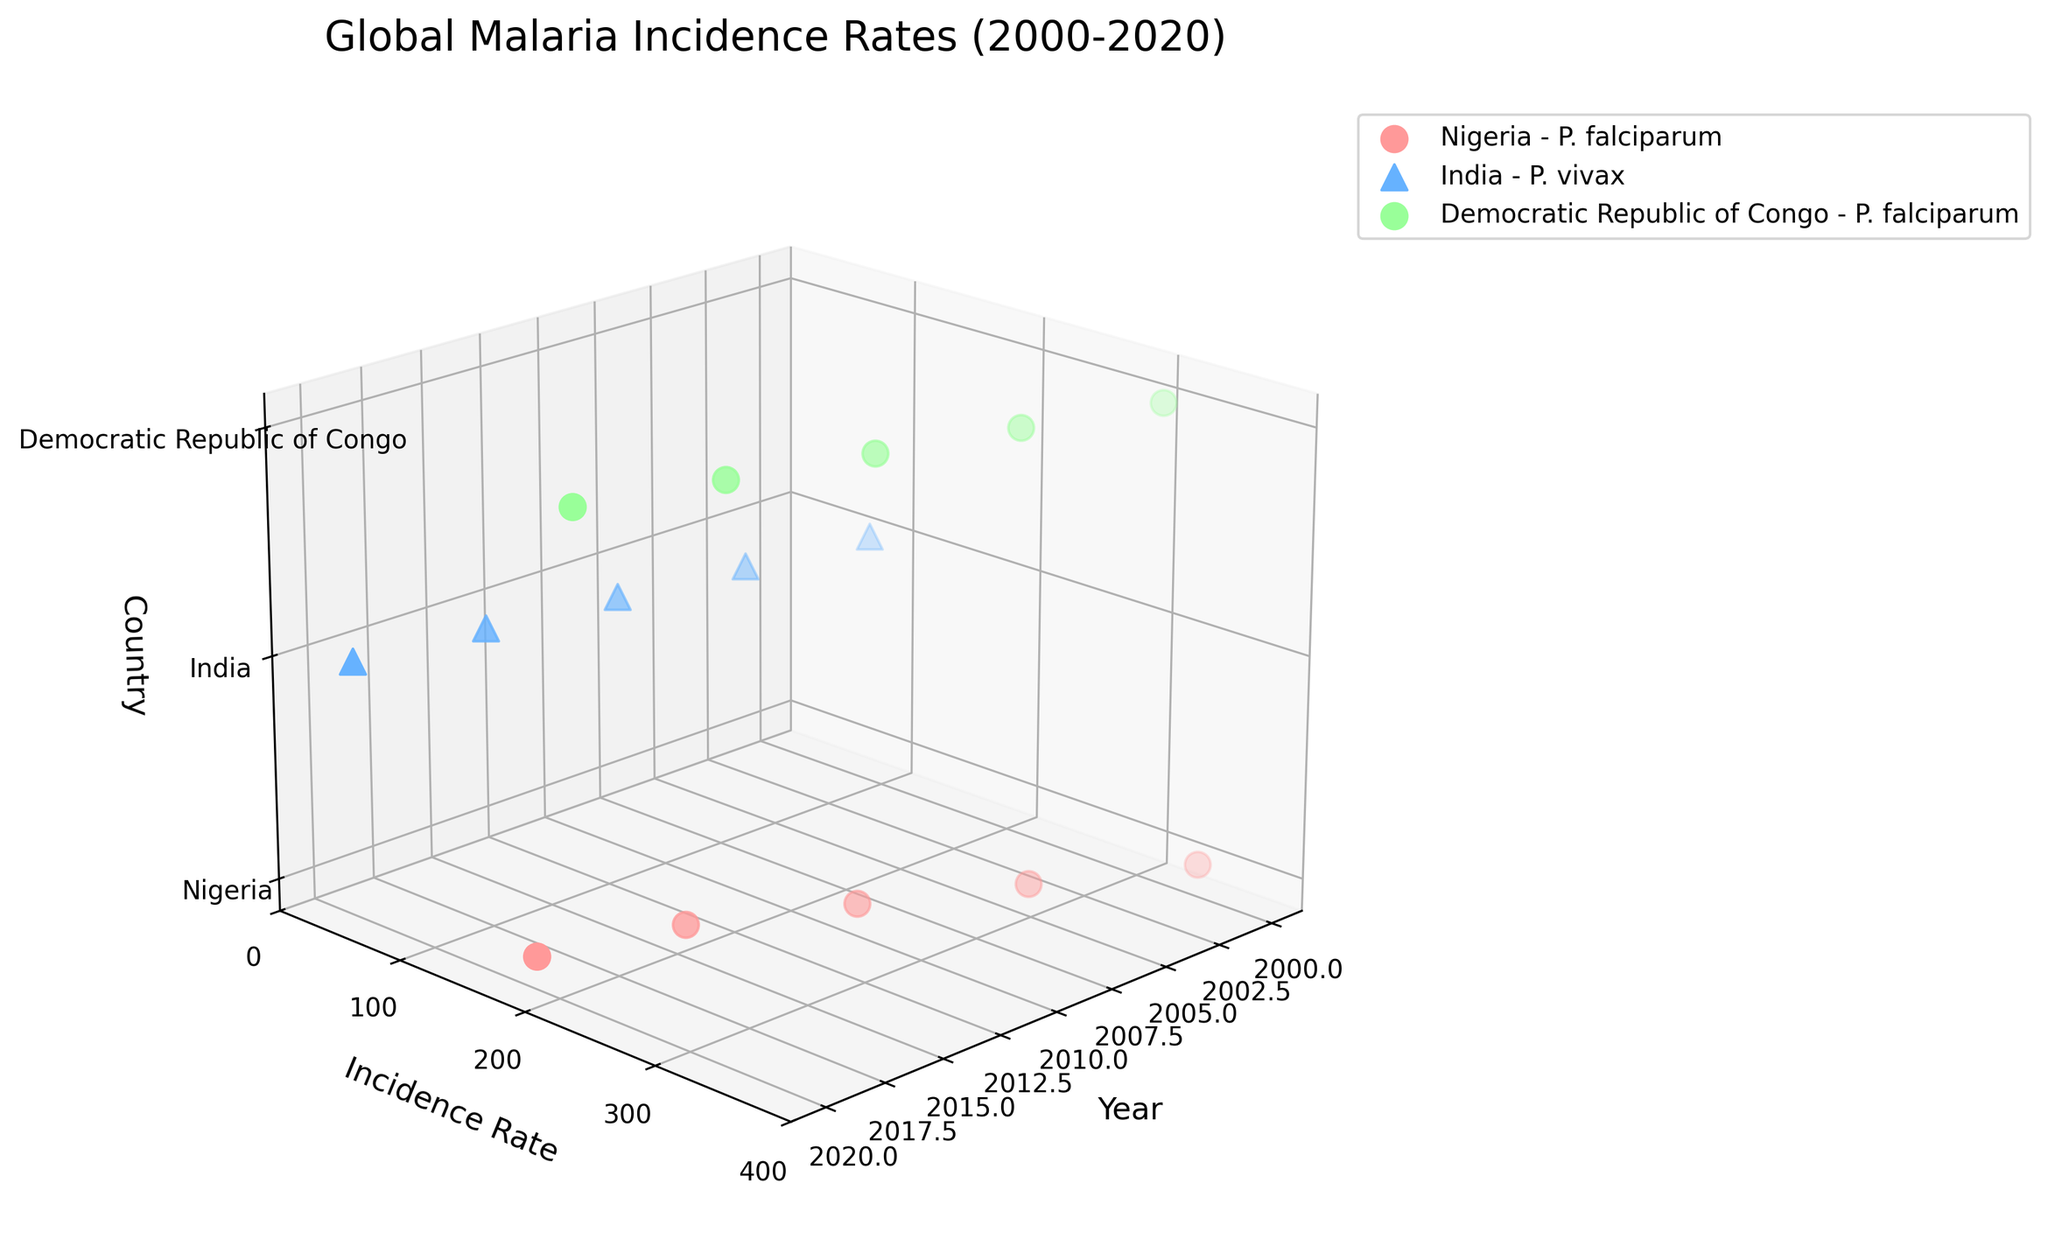What's the title of the figure? The title is located at the top of the figure and it is supposed to summarize the overall content.
Answer: Global Malaria Incidence Rates (2000-2020) Which country has the highest malaria incidence rate in 2020? To find the highest incidence rate in 2020, look at the data points for the year 2020 along the x-axis and then compare the incidence rates (y-axis) for each country (z-axis).
Answer: Nigeria What is the trend of malaria incidence rates in Nigeria over the years? Observe the data points for Nigeria distributed along the x-axis (years) and see how the y-axis values (incidence rates) change over time.
Answer: Decreasing Which Plasmodium species is present in India according to the figure? Identify the markers (shapes) associated with data points for India. The legend explains which shapes correspond to which Plasmodium species.
Answer: P. vivax What color represents Nigeria in the plot? Using the legend, locate the color associated with Nigeria's data points.
Answer: Red What is the difference in the malaria incidence rate of Nigeria between 2000 and 2020? Find and note down the incidence rates for Nigeria in the years 2000 and 2020 and then compute the difference.
Answer: 162.9 Which country showed a decreasing incidence rate for P. falciparum from 2000 to 2015? Identify the data points for P. falciparum (marker type) from 2000 to 2015 and examine their trends in each country.
Answer: Democratic Republic of Congo How does the incidence rate trend in India compare between 2005 and 2010? Locate the incidence rates for India in the years 2005 and 2010 and compare them to see whether they increased or decreased.
Answer: Decreased Which country has shown a consistently decreasing trend in malaria incidence rates for P. falciparum over the observed years? For each country, track the y-axis values for P. falciparum data points across all years and identify which country shows a consistently decreasing trend.
Answer: Nigeria How do the incidence rates for P. falciparum in the Democratic Republic of Congo compare to those in Nigeria in 2015? Look at the y-axis values for both countries for P. falciparum in 2015 and compare them directly.
Answer: DR Congo is higher 